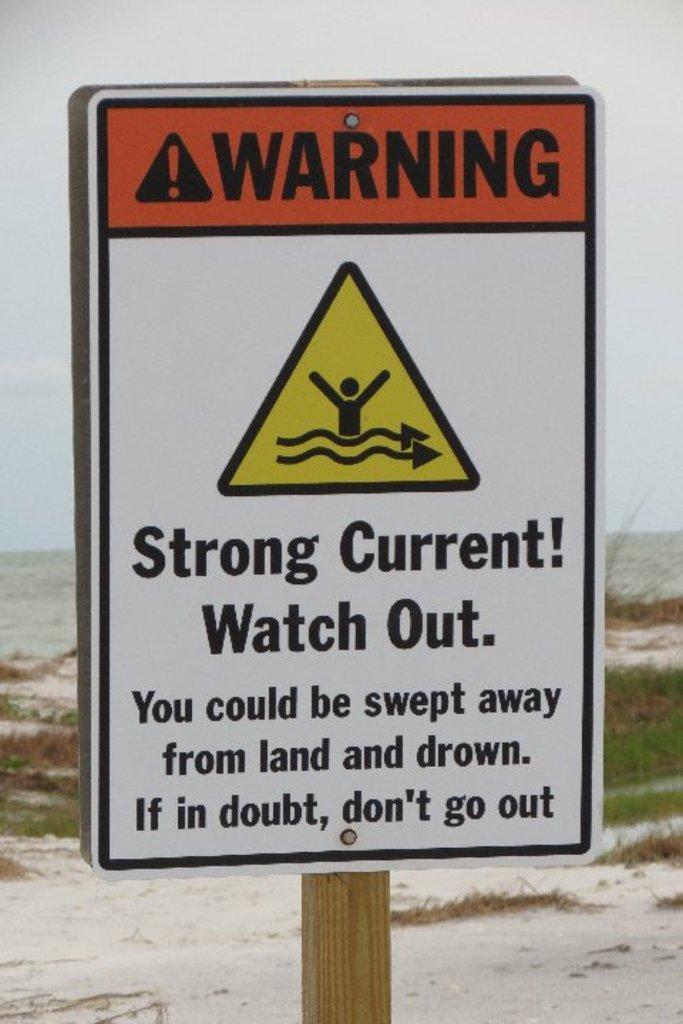Please provide a concise description of this image. In this image, we can see a name board with wooden pole. Background we can see grass, ground and sky. 